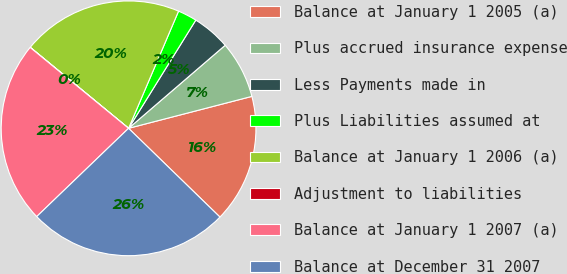Convert chart to OTSL. <chart><loc_0><loc_0><loc_500><loc_500><pie_chart><fcel>Balance at January 1 2005 (a)<fcel>Plus accrued insurance expense<fcel>Less Payments made in<fcel>Plus Liabilities assumed at<fcel>Balance at January 1 2006 (a)<fcel>Adjustment to liabilities<fcel>Balance at January 1 2007 (a)<fcel>Balance at December 31 2007<nl><fcel>16.3%<fcel>7.27%<fcel>4.85%<fcel>2.43%<fcel>20.45%<fcel>0.02%<fcel>23.13%<fcel>25.55%<nl></chart> 